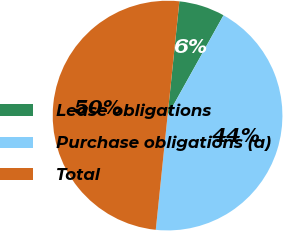Convert chart to OTSL. <chart><loc_0><loc_0><loc_500><loc_500><pie_chart><fcel>Lease obligations<fcel>Purchase obligations (a)<fcel>Total<nl><fcel>6.46%<fcel>43.54%<fcel>50.0%<nl></chart> 